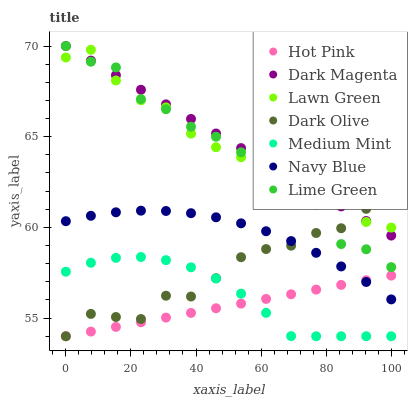Does Hot Pink have the minimum area under the curve?
Answer yes or no. Yes. Does Dark Magenta have the maximum area under the curve?
Answer yes or no. Yes. Does Lawn Green have the minimum area under the curve?
Answer yes or no. No. Does Lawn Green have the maximum area under the curve?
Answer yes or no. No. Is Hot Pink the smoothest?
Answer yes or no. Yes. Is Lime Green the roughest?
Answer yes or no. Yes. Is Lawn Green the smoothest?
Answer yes or no. No. Is Lawn Green the roughest?
Answer yes or no. No. Does Medium Mint have the lowest value?
Answer yes or no. Yes. Does Lawn Green have the lowest value?
Answer yes or no. No. Does Lime Green have the highest value?
Answer yes or no. Yes. Does Lawn Green have the highest value?
Answer yes or no. No. Is Medium Mint less than Lawn Green?
Answer yes or no. Yes. Is Lawn Green greater than Hot Pink?
Answer yes or no. Yes. Does Dark Magenta intersect Dark Olive?
Answer yes or no. Yes. Is Dark Magenta less than Dark Olive?
Answer yes or no. No. Is Dark Magenta greater than Dark Olive?
Answer yes or no. No. Does Medium Mint intersect Lawn Green?
Answer yes or no. No. 